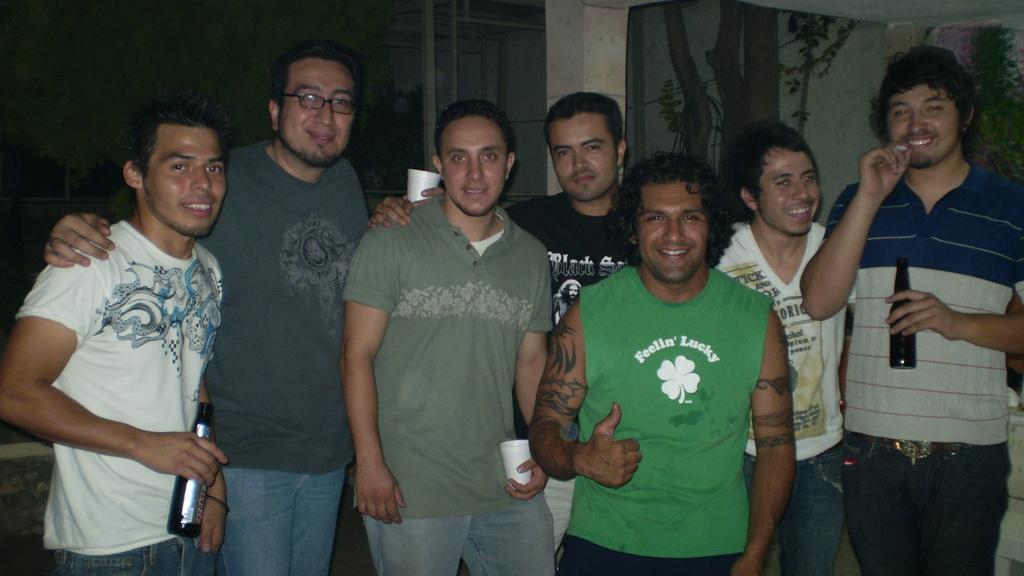Describe this image in one or two sentences. In this image I can see a group of men are standing and smiling, few of them are holding the beer bottles in their hands, few of them are holding the glasses. 